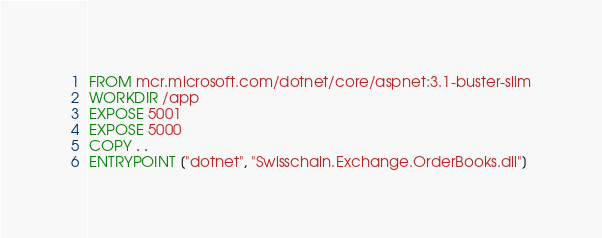<code> <loc_0><loc_0><loc_500><loc_500><_Dockerfile_>FROM mcr.microsoft.com/dotnet/core/aspnet:3.1-buster-slim
WORKDIR /app
EXPOSE 5001
EXPOSE 5000
COPY . .
ENTRYPOINT ["dotnet", "Swisschain.Exchange.OrderBooks.dll"]
</code> 